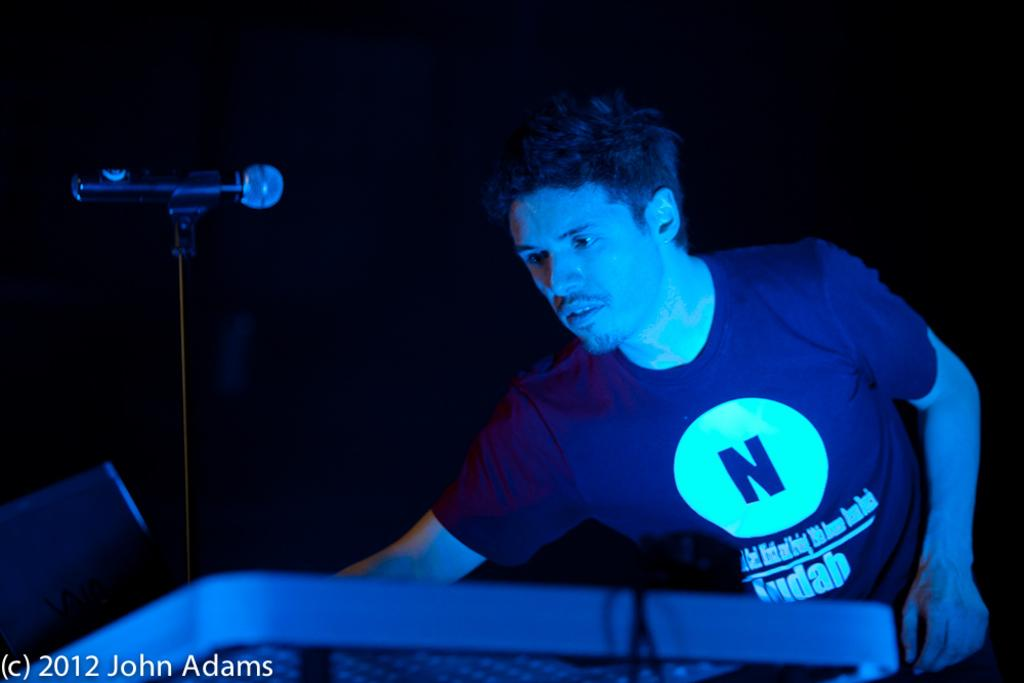What is the main object in the image? There is a table in the image. What is placed on the table? There is a microphone (mic) on the table. Who is present in the image? There is a man standing behind the table. What type of steel is used to make the man's knee in the image? There is no mention of a man's knee or steel in the image; it only features a table with a microphone on it and a man standing behind the table. 